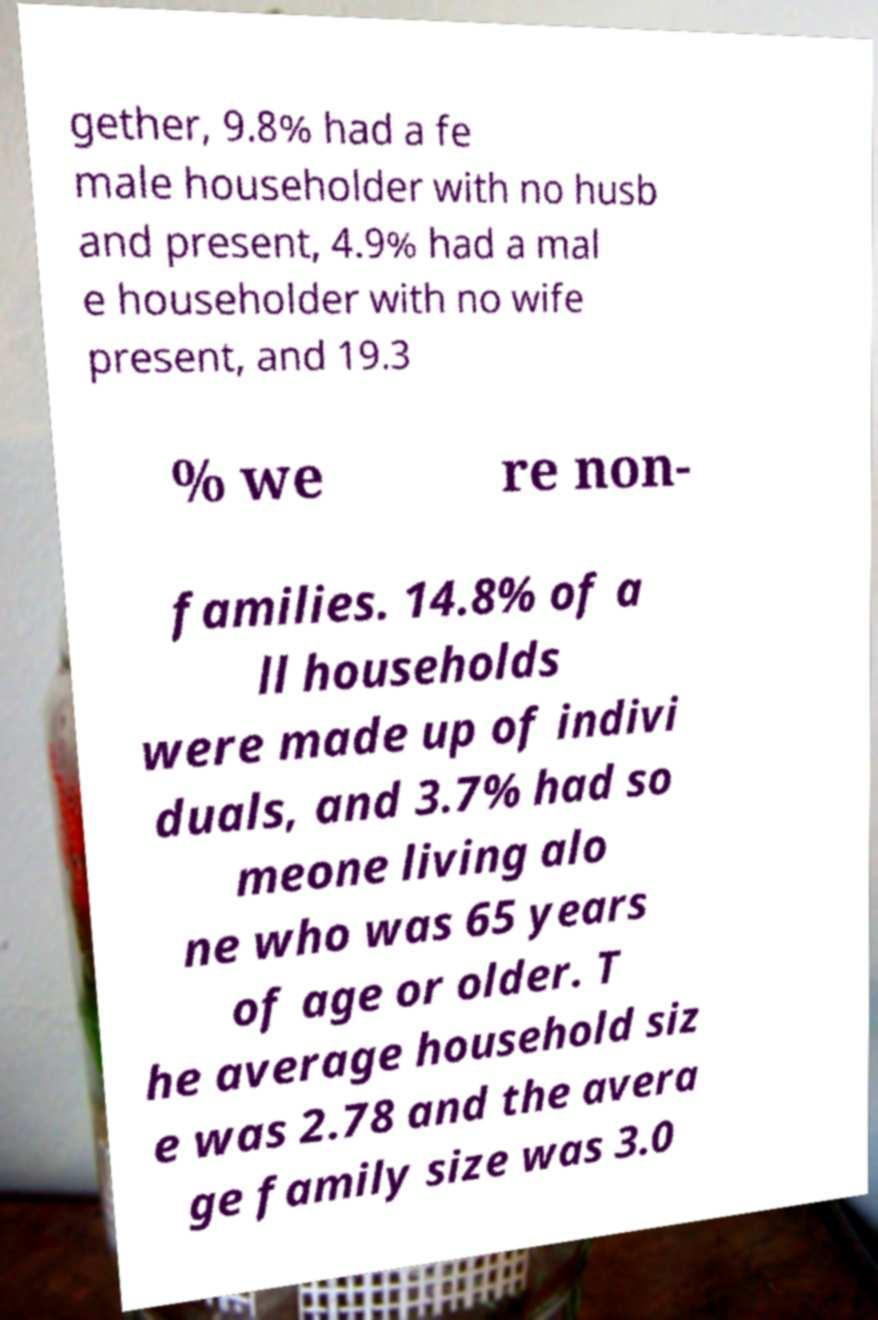Could you extract and type out the text from this image? gether, 9.8% had a fe male householder with no husb and present, 4.9% had a mal e householder with no wife present, and 19.3 % we re non- families. 14.8% of a ll households were made up of indivi duals, and 3.7% had so meone living alo ne who was 65 years of age or older. T he average household siz e was 2.78 and the avera ge family size was 3.0 